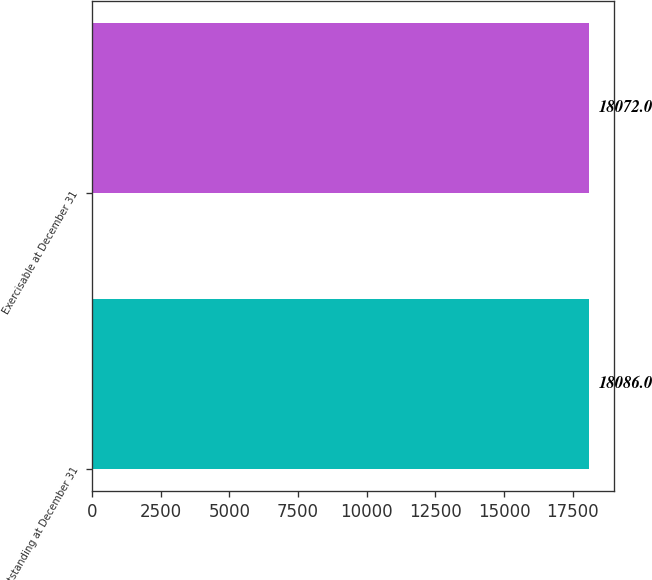<chart> <loc_0><loc_0><loc_500><loc_500><bar_chart><fcel>Outstanding at December 31<fcel>Exercisable at December 31<nl><fcel>18086<fcel>18072<nl></chart> 